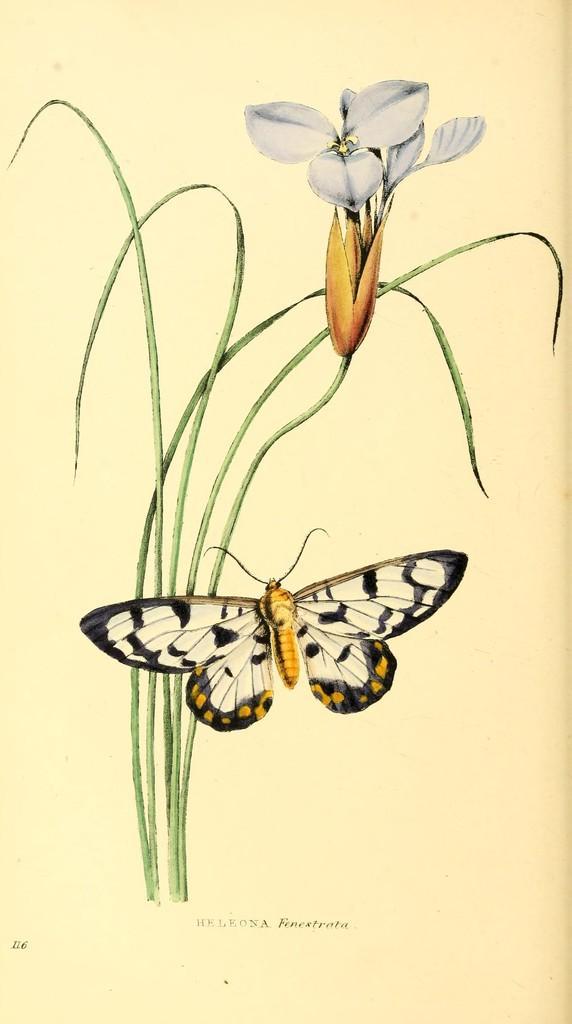In one or two sentences, can you explain what this image depicts? In the image there is an art of a flower plant with a butterfly in front on a paper. 